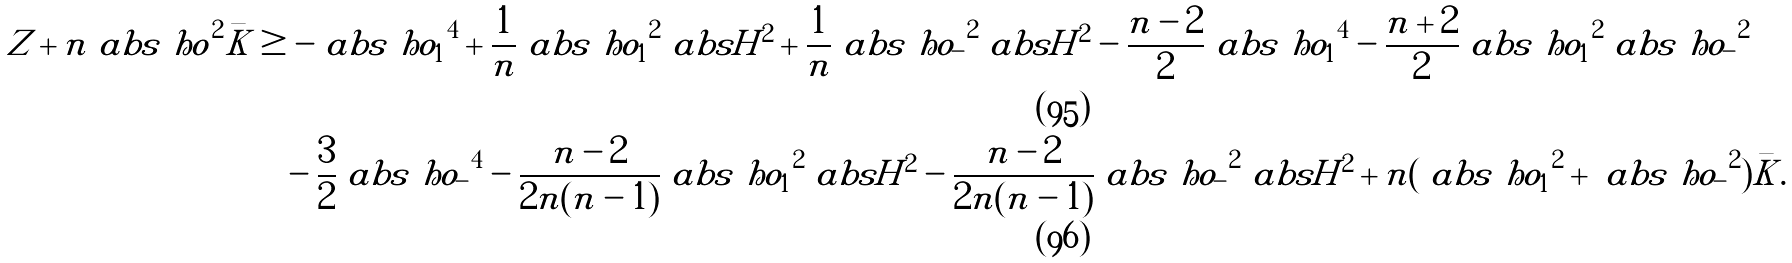Convert formula to latex. <formula><loc_0><loc_0><loc_500><loc_500>Z + n \ a b s { \ h o } ^ { 2 } \bar { K } & \geq - \ a b s { \ h o _ { 1 } } ^ { 4 } + \frac { 1 } { n } \ a b s { \ h o _ { 1 } } ^ { 2 } \ a b s { H } ^ { 2 } + \frac { 1 } { n } \ a b s { \ h o _ { - } } ^ { 2 } \ a b s { H } ^ { 2 } - \frac { n - 2 } { 2 } \ a b s { \ h o _ { 1 } } ^ { 4 } - \frac { n + 2 } { 2 } \ a b s { \ h o _ { 1 } } ^ { 2 } \ a b s { \ h o _ { - } } ^ { 2 } \\ & \quad - \frac { 3 } { 2 } \ a b s { \ h o _ { - } } ^ { 4 } - \frac { n - 2 } { 2 n ( n - 1 ) } \ a b s { \ h o _ { 1 } } ^ { 2 } \ a b s { H } ^ { 2 } - \frac { n - 2 } { 2 n ( n - 1 ) } \ a b s { \ h o _ { - } } ^ { 2 } \ a b s { H } ^ { 2 } + n ( \ a b s { \ h o _ { 1 } } ^ { 2 } + \ a b s { \ h o _ { - } } ^ { 2 } ) \bar { K } .</formula> 